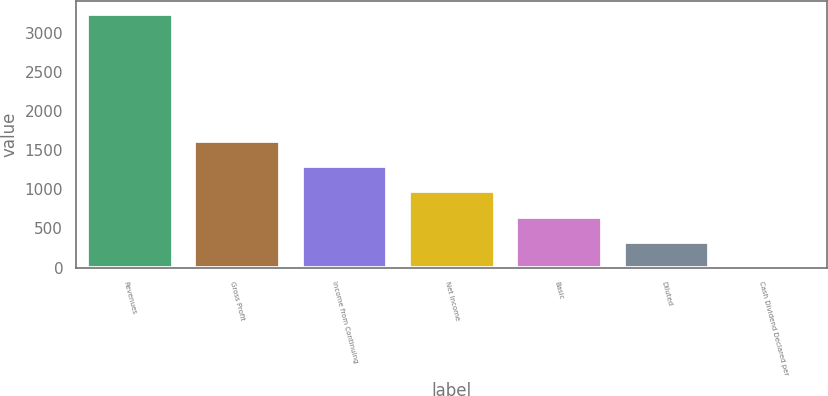<chart> <loc_0><loc_0><loc_500><loc_500><bar_chart><fcel>Revenues<fcel>Gross Profit<fcel>Income from Continuing<fcel>Net Income<fcel>Basic<fcel>Diluted<fcel>Cash Dividend Declared per<nl><fcel>3240.1<fcel>1620.11<fcel>1296.12<fcel>972.12<fcel>648.13<fcel>324.14<fcel>0.15<nl></chart> 